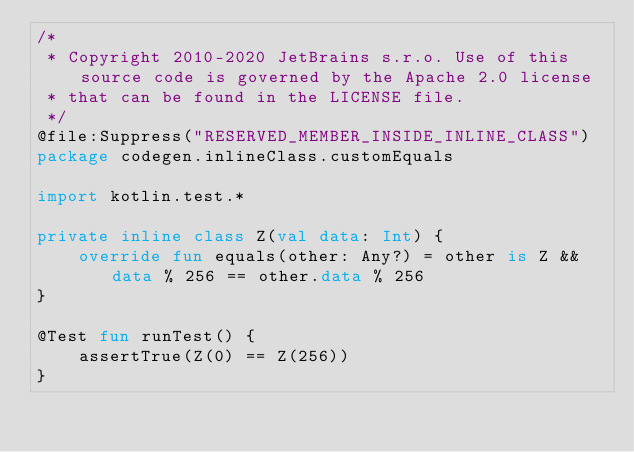<code> <loc_0><loc_0><loc_500><loc_500><_Kotlin_>/*
 * Copyright 2010-2020 JetBrains s.r.o. Use of this source code is governed by the Apache 2.0 license
 * that can be found in the LICENSE file.
 */
@file:Suppress("RESERVED_MEMBER_INSIDE_INLINE_CLASS")
package codegen.inlineClass.customEquals

import kotlin.test.*

private inline class Z(val data: Int) {
    override fun equals(other: Any?) = other is Z && data % 256 == other.data % 256
}

@Test fun runTest() {
    assertTrue(Z(0) == Z(256))
}
</code> 